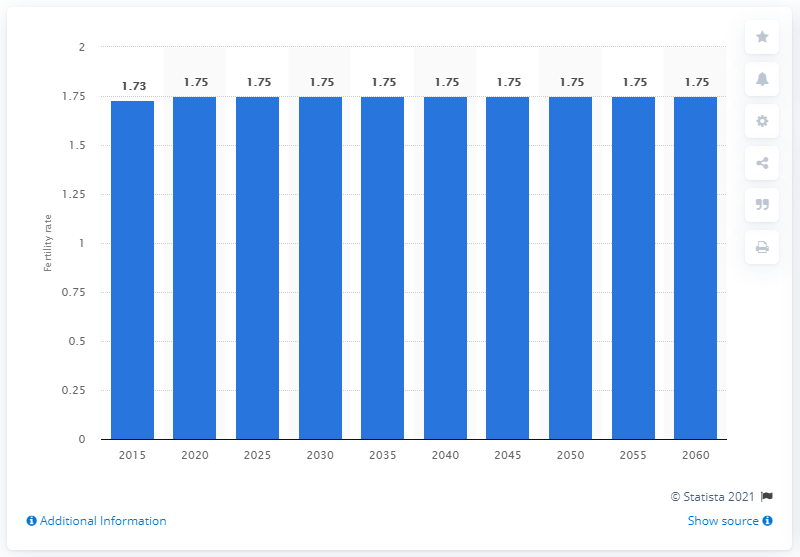Give some essential details in this illustration. The average number of children per woman in the Netherlands between 2015 and 2060 is expected to be 1.75. 